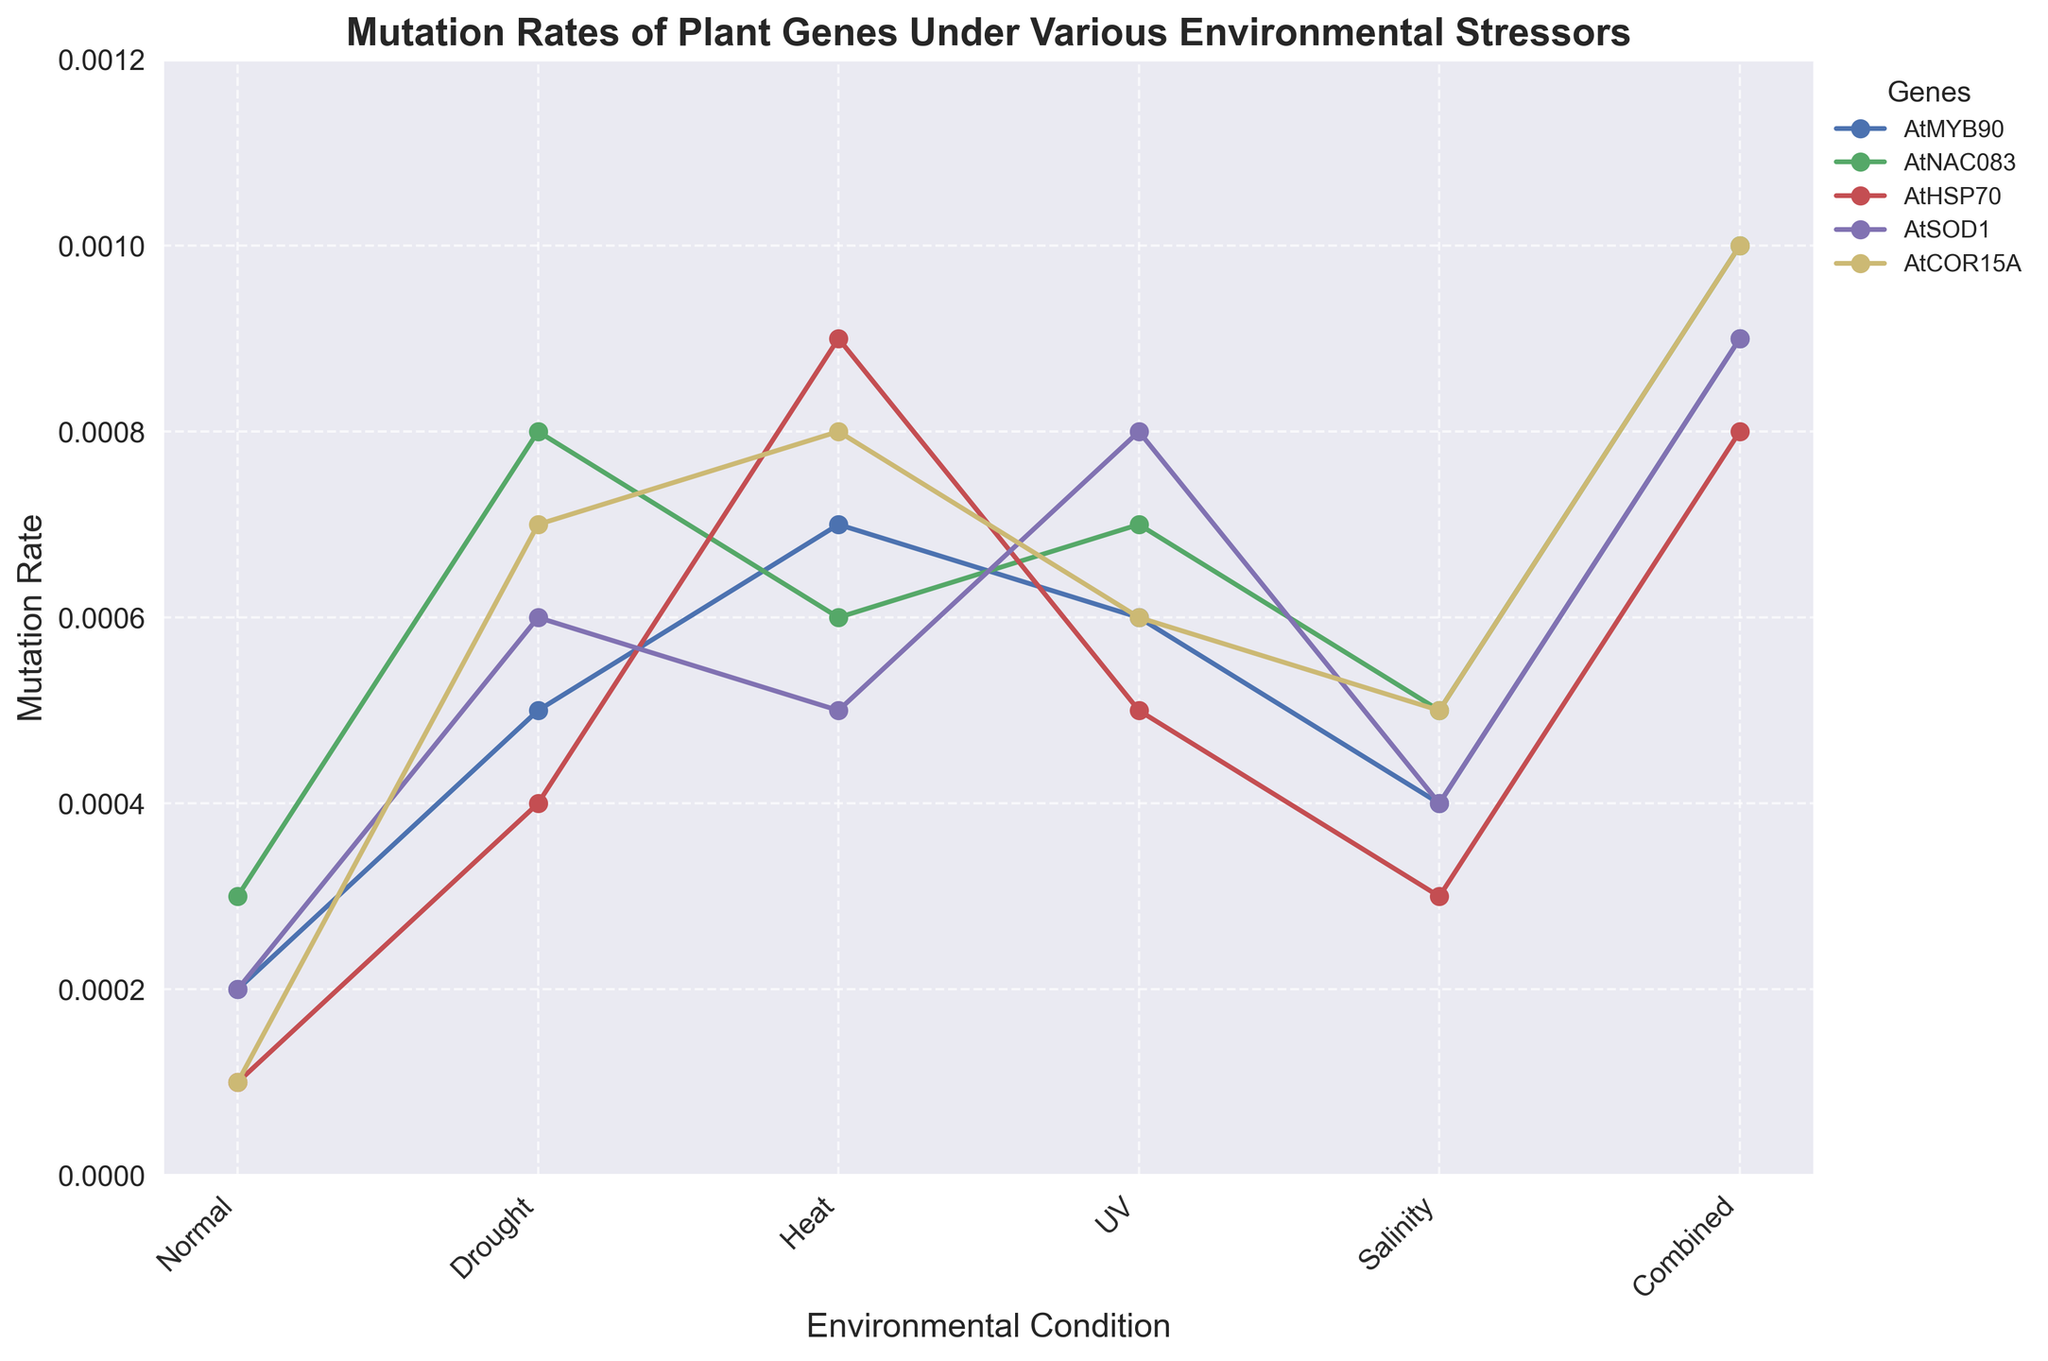Which gene shows the highest mutation rate under normal conditions? To determine this, look at the values associated with each gene for the 'Normal' condition. The values are as follows: AtMYB90 (0.0002), AtNAC083 (0.0003), AtHSP70 (0.0001), AtSOD1 (0.0002), and AtCOR15A (0.0001). The highest value among these is 0.0003 for AtNAC083.
Answer: AtNAC083 How does the mutation rate of AtHSP70 under heat stress compare to its rate under normal conditions? To compare these values, look at the mutation rate of AtHSP70 for 'Heat' and 'Normal' conditions. The values are 0.0009 and 0.0001 respectively. The rate under heat stress is 0.0009, which is 0.0008 higher than the rate under normal conditions.
Answer: Higher by 0.0008 Which environmental stressor leads to the greatest increase in the mutation rate of AtSOD1 compared to normal conditions? Compare the mutation rates of AtSOD1 under each stressor to its rate under normal conditions. The rates are as follows: Normal (0.0002), Drought (0.0006), Heat (0.0005), UV (0.0008), Salinity (0.0004), Combined (0.0009). The greatest increase is seen under 'Combined' with a difference of 0.0009 - 0.0002 = 0.0007.
Answer: Combined What is the average mutation rate of AtCOR15A across all environmental stressors including normal conditions? To calculate the average, sum the mutation rates of AtCOR15A under all conditions: 0.0001 (Normal) + 0.0007 (Drought) + 0.0008 (Heat) + 0.0006 (UV) + 0.0005 (Salinity) + 0.0010 (Combined) = 0.0037. Then, divide by the number of conditions (6): 0.0037 / 6 = 0.0006167.
Answer: 0.0006167 Which gene shows the most consistent mutation rate across all conditions? Examine the variation in the mutation rates for each gene. AtMYB90 (0.0002 to 0.0009), AtNAC083 (0.0003 to 0.0010), AtHSP70 (0.0001 to 0.0009), AtSOD1 (0.0002 to 0.0009), AtCOR15A (0.0001 to 0.0010). The smallest range of values is observed in AtMYB90 which ranges from 0.0002 to 0.0009, but the most consistent (smallest maximum variance) appears to be in AtMYB90 with a range 0.0007.
Answer: AtMYB90 What is the combined mutation rate for all genes under drought conditions? Sum the mutation rates for all genes under 'Drought': AtMYB90 (0.0005) + AtNAC083 (0.0008) + AtHSP70 (0.0004) + AtSOD1 (0.0006) + AtCOR15A (0.0007) = 0.0030.
Answer: 0.0030 How does the mutation rate of AtHSP70 in UV stress compare to AtMYB90 under drought conditions? Compare the values: AtHSP70 in UV is 0.0005, and AtMYB90 under Drought is 0.0005. Since 0.0005 == 0.0005, they are equal.
Answer: Equal 